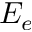Convert formula to latex. <formula><loc_0><loc_0><loc_500><loc_500>E _ { e }</formula> 